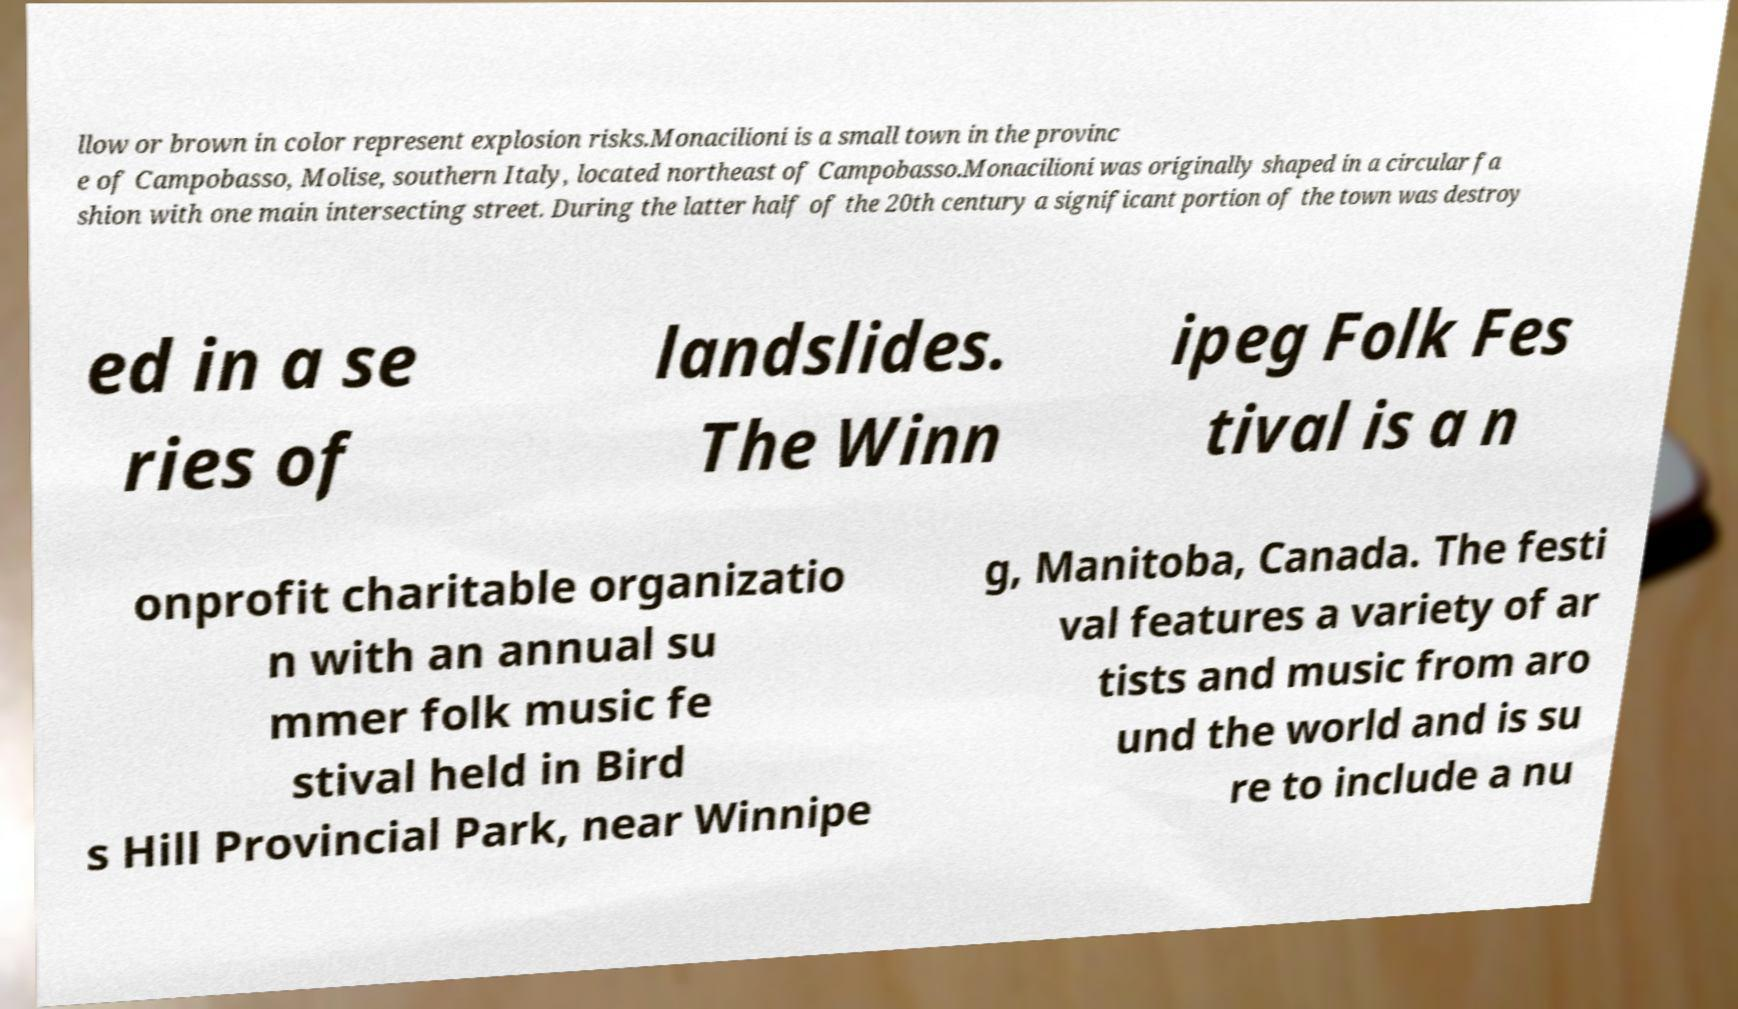What messages or text are displayed in this image? I need them in a readable, typed format. llow or brown in color represent explosion risks.Monacilioni is a small town in the provinc e of Campobasso, Molise, southern Italy, located northeast of Campobasso.Monacilioni was originally shaped in a circular fa shion with one main intersecting street. During the latter half of the 20th century a significant portion of the town was destroy ed in a se ries of landslides. The Winn ipeg Folk Fes tival is a n onprofit charitable organizatio n with an annual su mmer folk music fe stival held in Bird s Hill Provincial Park, near Winnipe g, Manitoba, Canada. The festi val features a variety of ar tists and music from aro und the world and is su re to include a nu 